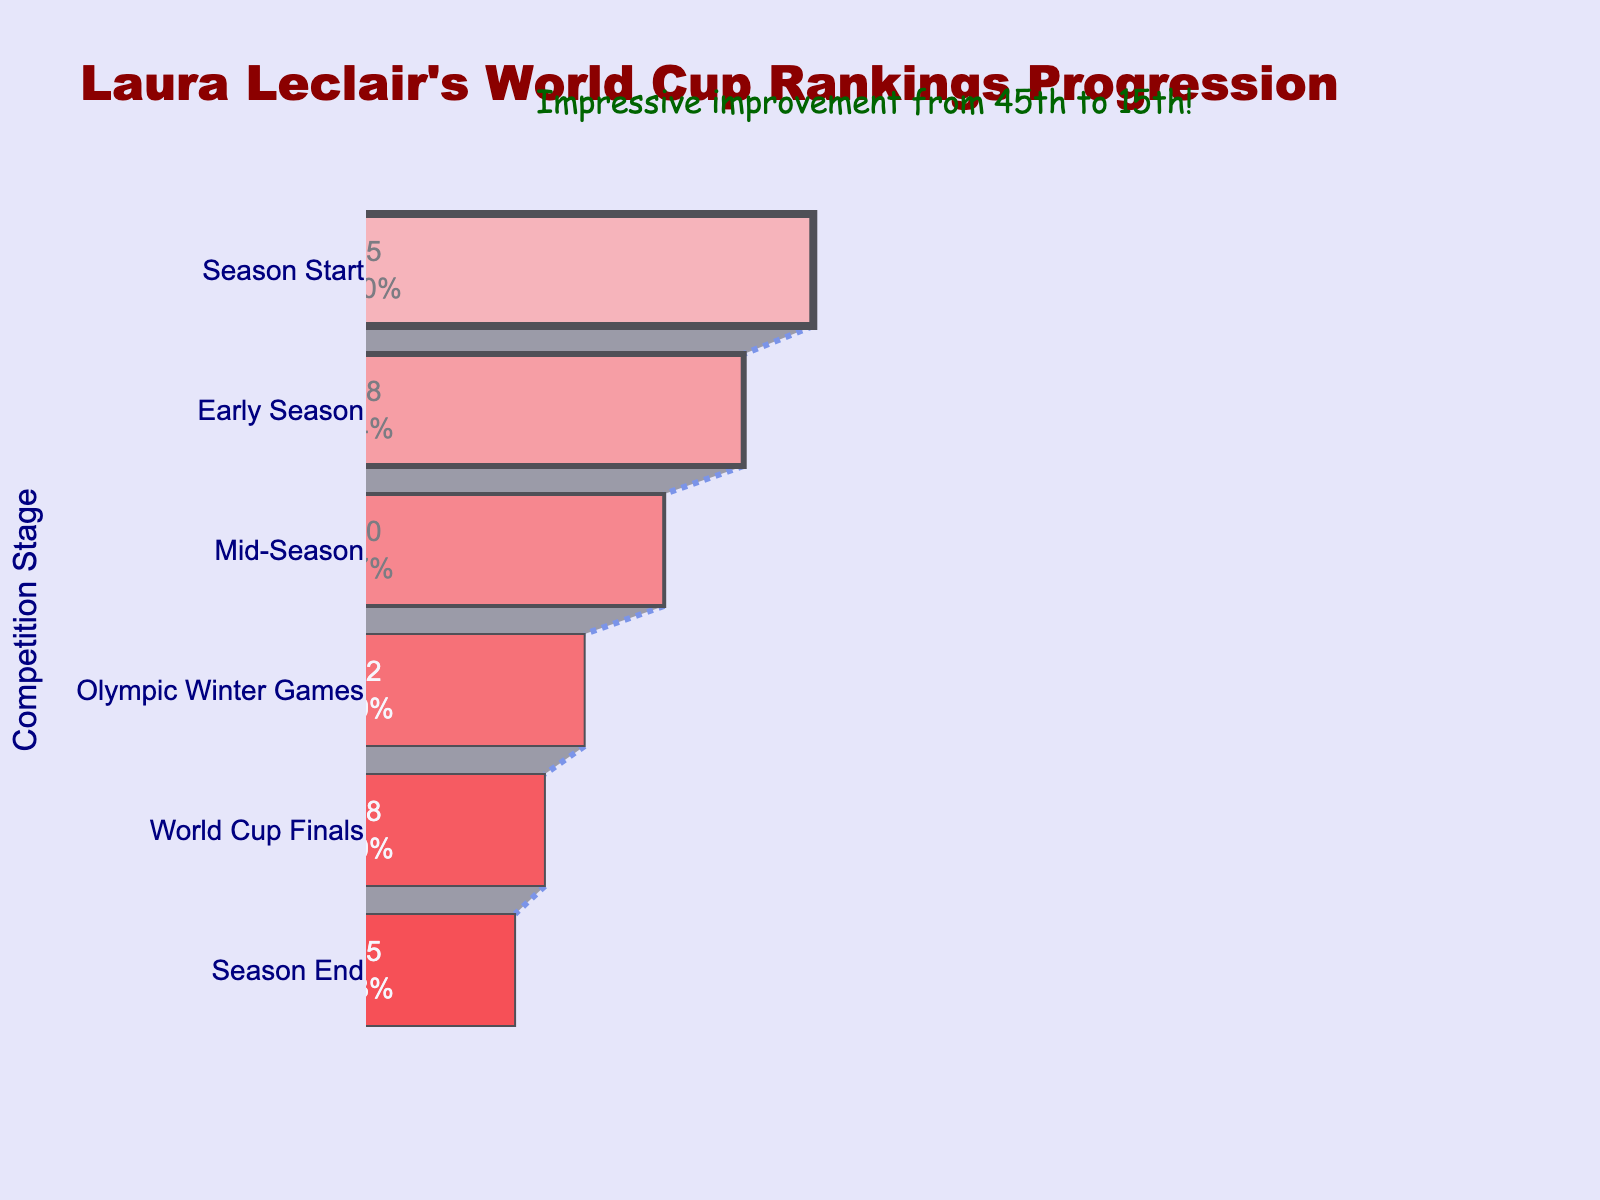What is the title of the chart? The title of the chart is displayed at the top center. It reads "Laura Leclair's World Cup Rankings Progression."
Answer: Laura Leclair's World Cup Rankings Progression How many competition stages are represented in the chart? The funnel chart includes six distinct competition stages listed on the left side: Season Start, Early Season, Mid-Season, Olympic Winter Games, World Cup Finals, and Season End.
Answer: Six What was Laura Leclair's ranking at the Season Start? At the Season Start stage, the funnel chart shows Laura Leclair's ranking as 45, located at the top of the funnel.
Answer: 45 How much did Laura Leclair's ranking improve from the Season Start to the Early Season? Laura Leclair's ranking improved from 45 at the Season Start to 38 in the Early Season. The difference is calculated as 45 - 38 = 7.
Answer: 7 What was Laura Leclair's ranking at the Olympic Winter Games stage? According to the funnel chart, Laura Leclair's ranking at the Olympic Winter Games stage was 22. This is shown mid-way down the funnel.
Answer: 22 What is the percentage difference in Laura Leclair's ranking from the season start to the season end? The percentage difference is calculated with the formula [(Initial Value - Final Value) / Initial Value] * 100%. Here, it is [(45 - 15) / 45] * 100% = 66.67%.
Answer: 66.67% Which two stages show the greatest improvement in Laura Leclair's ranking? To determine the greatest improvement, compare the differences between successive stages. The largest rank improvement occurs between the Mid-Season (30) and Olympic Winter Games (22), with an 8-rank improvement.
Answer: Mid-Season to Olympic Winter Games Did Laura Leclair's ranking ever worsen at any stage during the season? By visually checking each descending stage in the funnel chart, we see that Laura Leclair's ranking consistently improved throughout the season. There are no stages where her ranking worsened.
Answer: No Is the value '15' marked with a different color compared to the other values in the chart? All values in the funnel chart are colored with shades of red, with the bottom-most '15' in the darkest red (#FF0000). These values have colored outlines but no different shades indicating uniqueness of the final value's significance.
Answer: No What is the combined improvement in rankings from Early Season to Season End? The combined improvement from Early Season to Season End is the sum of improvements at each stage within this period: (38 to 30) + (30 to 22) + (22 to 18) + (18 to 15). Calculating each difference (8+8+4+3), we get a total improvement of 23.
Answer: 23 